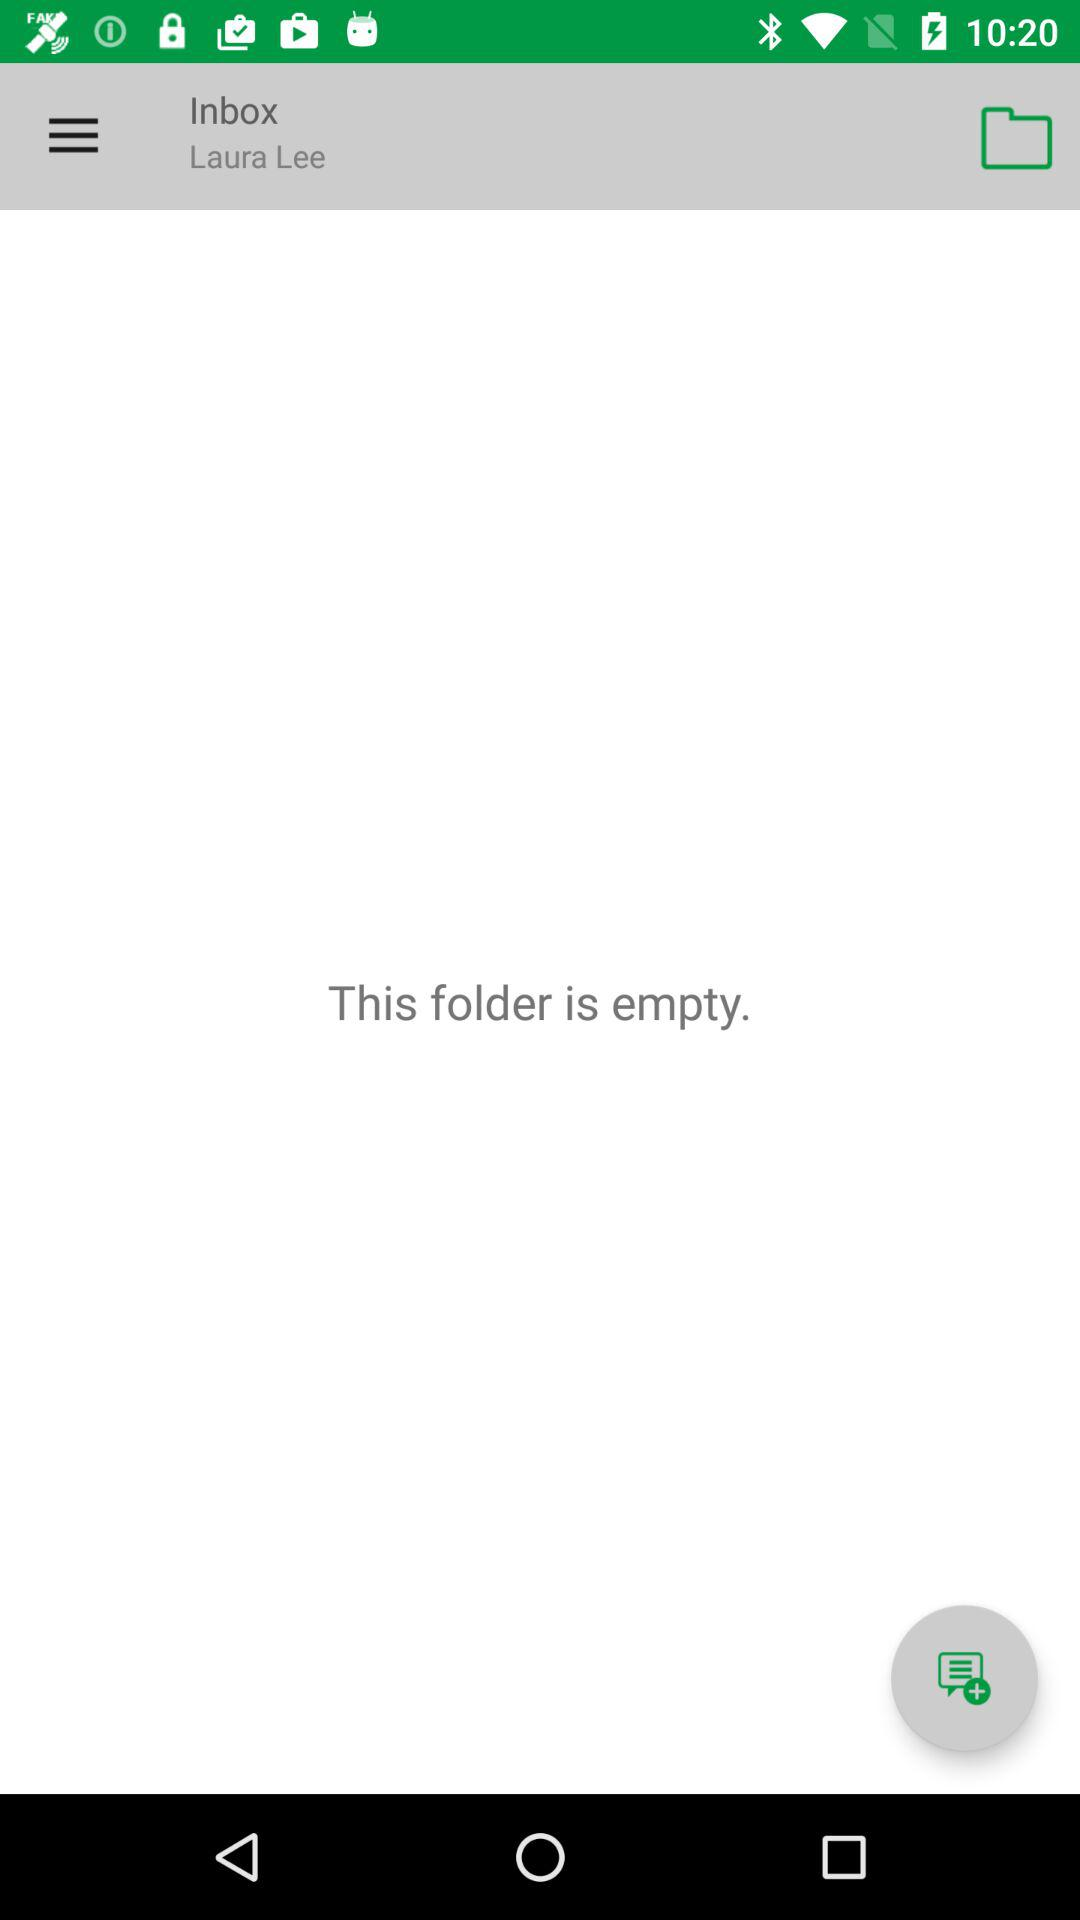Is there any message in the folder? The folder is empty. 